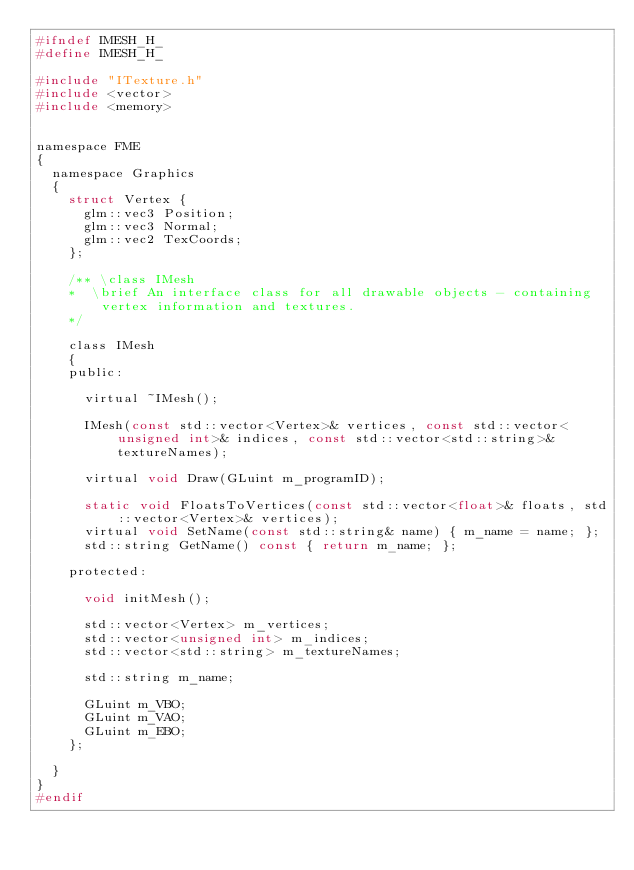<code> <loc_0><loc_0><loc_500><loc_500><_C_>#ifndef IMESH_H_
#define IMESH_H_

#include "ITexture.h"
#include <vector>
#include <memory>


namespace FME
{
	namespace Graphics
	{
		struct Vertex {
			glm::vec3 Position;
			glm::vec3 Normal;
			glm::vec2 TexCoords;
		};

		/** \class IMesh
		*  \brief An interface class for all drawable objects - containing vertex information and textures. 
		*/

		class IMesh
		{
		public:

			virtual ~IMesh();

			IMesh(const std::vector<Vertex>& vertices, const std::vector<unsigned int>& indices, const std::vector<std::string>& textureNames);

			virtual void Draw(GLuint m_programID);
			
			static void FloatsToVertices(const std::vector<float>& floats, std::vector<Vertex>& vertices);
			virtual void SetName(const std::string& name) { m_name = name; };
			std::string GetName() const { return m_name; };

		protected:

			void initMesh();

			std::vector<Vertex> m_vertices;
			std::vector<unsigned int> m_indices;
			std::vector<std::string> m_textureNames;

			std::string m_name;

			GLuint m_VBO;
			GLuint m_VAO;
			GLuint m_EBO;
		};

	}
}
#endif
</code> 